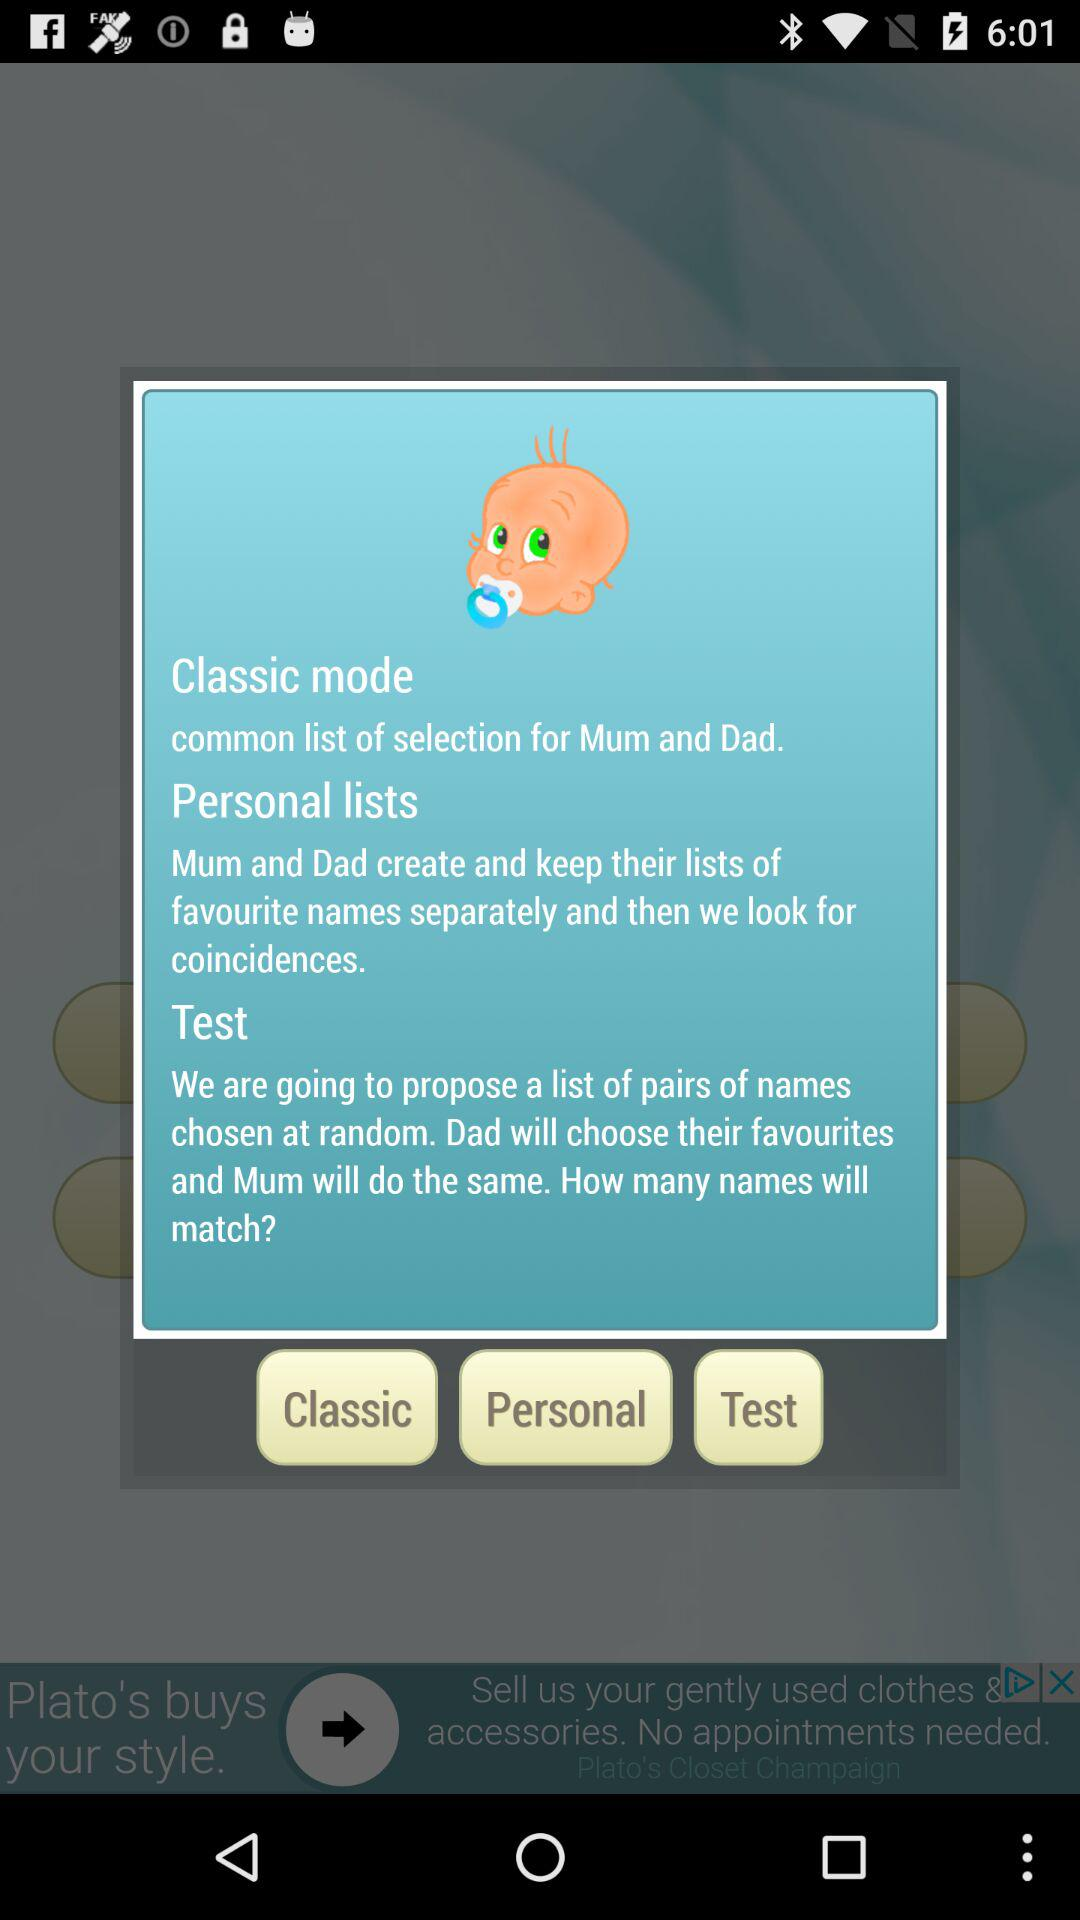How many different modes are available?
Answer the question using a single word or phrase. 3 